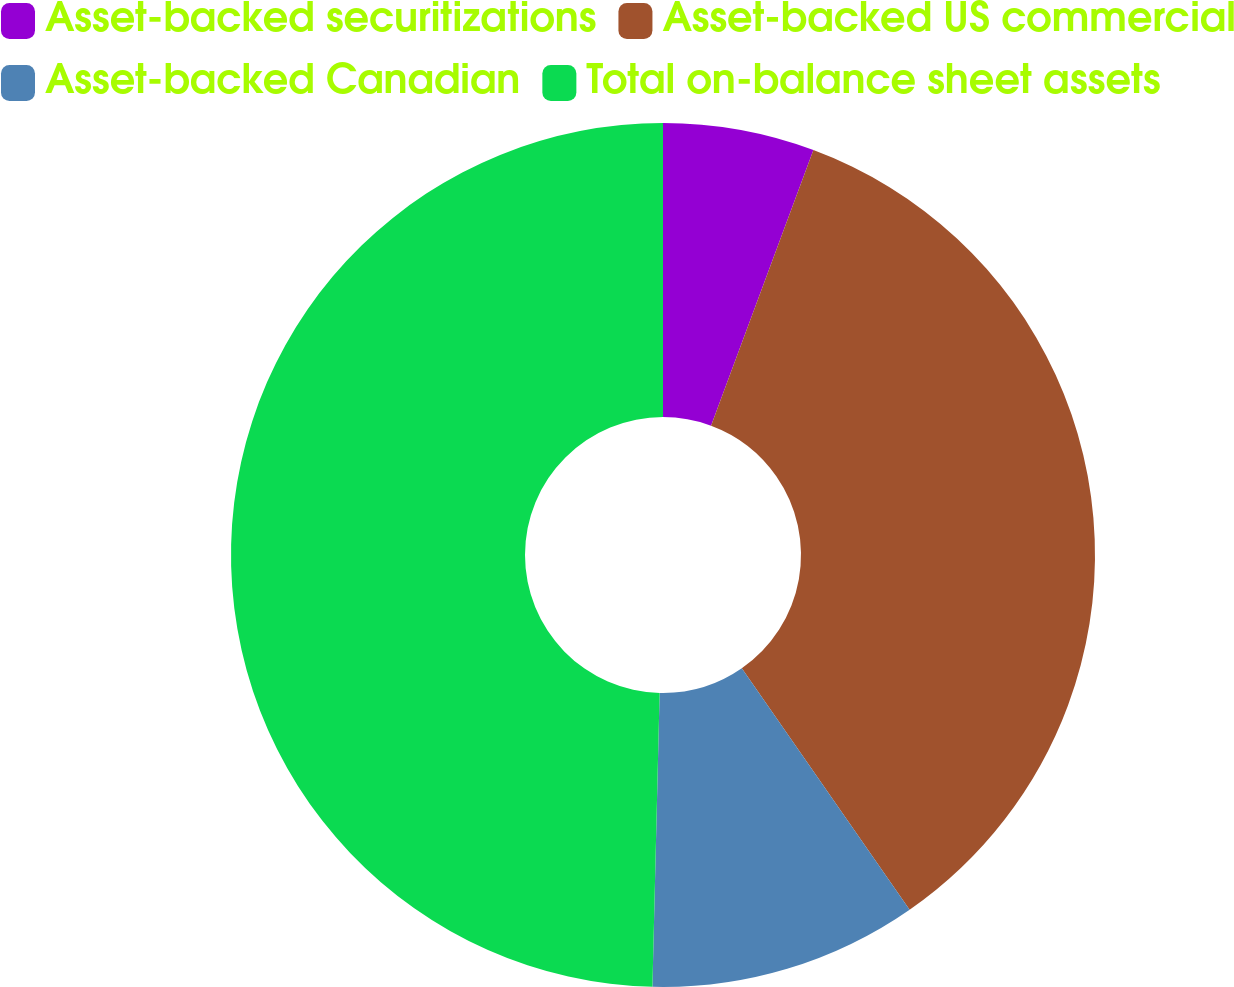Convert chart to OTSL. <chart><loc_0><loc_0><loc_500><loc_500><pie_chart><fcel>Asset-backed securitizations<fcel>Asset-backed US commercial<fcel>Asset-backed Canadian<fcel>Total on-balance sheet assets<nl><fcel>5.66%<fcel>34.67%<fcel>10.06%<fcel>49.61%<nl></chart> 